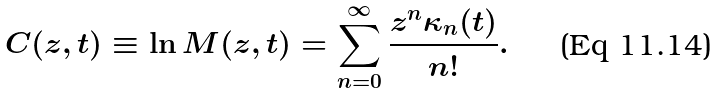Convert formula to latex. <formula><loc_0><loc_0><loc_500><loc_500>C ( z , t ) \equiv \ln M ( z , t ) = \sum _ { n = 0 } ^ { \infty } \frac { z ^ { n } \kappa _ { n } ( t ) } { n ! } .</formula> 